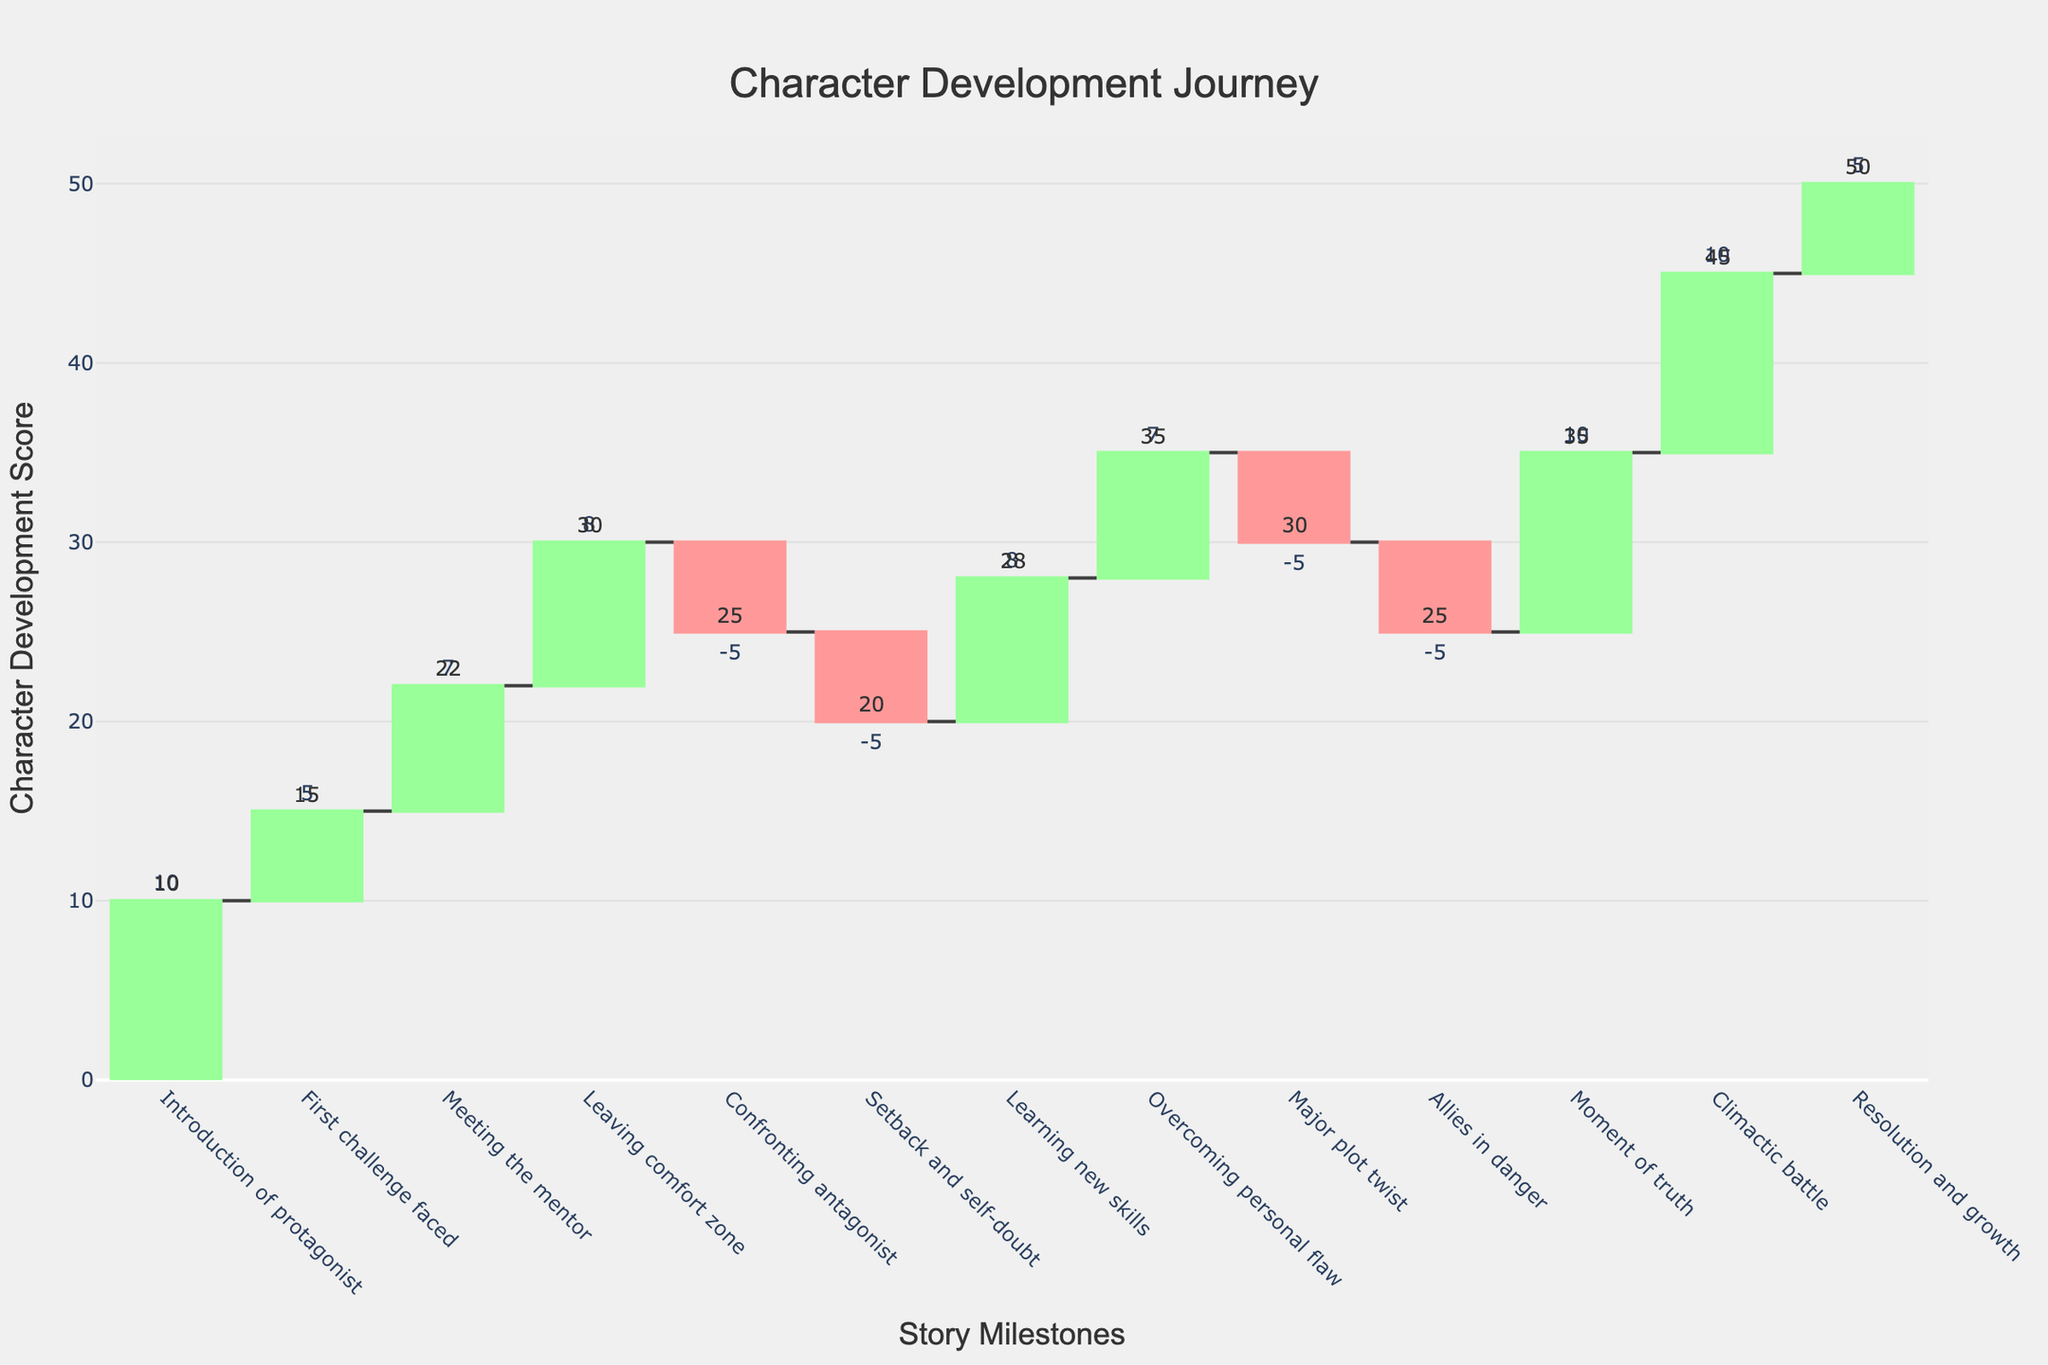What is the title of the chart? The title of the chart is usually displayed at the top of the figure. In this case, it reads "Character Development Journey".
Answer: Character Development Journey How many story milestones are represented in the chart? Each milestone corresponds to a character event listed on the x-axis, such as "Introduction of protagonist" and "Climactic battle". There are 13 events in total.
Answer: 13 Which story milestone shows the highest development score? By looking at the annotations on the chart, the milestone "Resolution and growth" has the highest development score of 50.
Answer: Resolution and growth What is the total change in the development score during "Learning new skills"? The text near "Learning new skills" shows a change of 8 in the character development score.
Answer: 8 During which two milestones does the protagonist face a decrease in development score? By identifying the decreasing changes (highlighted in red), "Confronting antagonist" and "Setback and self-doubt" are the milestones where the development score decreases.
Answer: Confronting antagonist and Setback and self-doubt What is the total increase in development score up to "Leaving comfort zone"? Sum the positive changes: 10 (Introduction) + 5 (First challenge) + 7 (Meeting mentor) + 8 (Leaving comfort zone) = 30
Answer: 30 By how much does the development score drop between "Leaving comfort zone" and "Setback and self-doubt"? Identify the values before and after: 30 (Leaving comfort zone) to 20 (Setback and self-doubt). Calculate the difference: 30 - 20 = 10.
Answer: 10 What is the overall trend in the development score after the "Major plot twist"? After the "Major plot twist" (score decreases), the score decreases again during "Allies in danger" and then increases at "Moment of truth" and onwards.
Answer: Decrease then increase Can you identify two consecutive milestones with the same directional change in score? "Setback and self-doubt" and "Major plot twist" both have descending changes, each showing a decrease of -5.
Answer: Setback and self-doubt and Major plot twist What is the average change in development score across all milestones? Sum all changes: 10 + 5 + 7 + 8 - 5 - 5 + 8 + 7 - 5 - 5 + 10 + 10 + 5 = 50. Average = 50 / 13 ≈ 3.85.
Answer: Approximately 3.85 